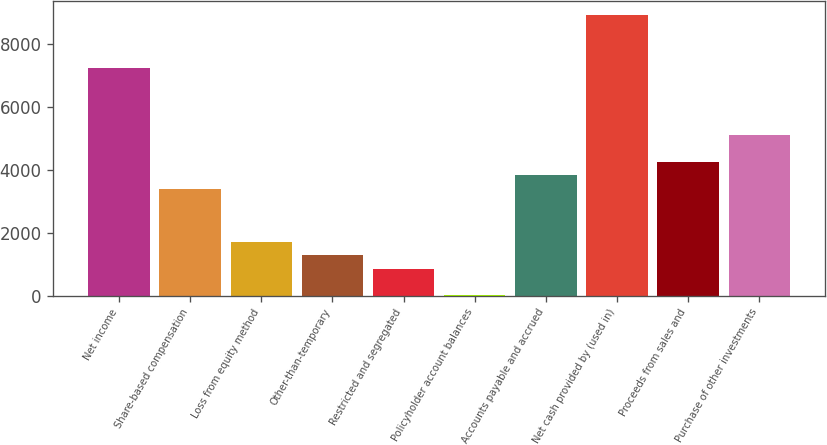Convert chart. <chart><loc_0><loc_0><loc_500><loc_500><bar_chart><fcel>Net income<fcel>Share-based compensation<fcel>Loss from equity method<fcel>Other-than-temporary<fcel>Restricted and segregated<fcel>Policyholder account balances<fcel>Accounts payable and accrued<fcel>Net cash provided by (used in)<fcel>Proceeds from sales and<fcel>Purchase of other investments<nl><fcel>7219.4<fcel>3401.6<fcel>1704.8<fcel>1280.6<fcel>856.4<fcel>8<fcel>3825.8<fcel>8916.2<fcel>4250<fcel>5098.4<nl></chart> 